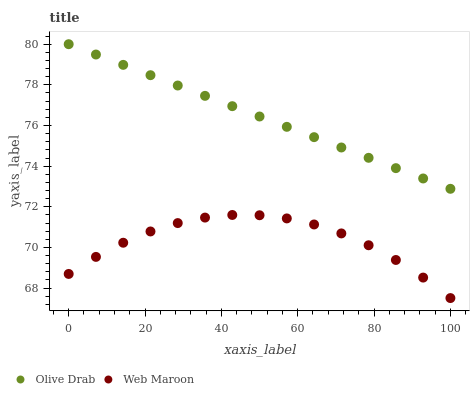Does Web Maroon have the minimum area under the curve?
Answer yes or no. Yes. Does Olive Drab have the maximum area under the curve?
Answer yes or no. Yes. Does Olive Drab have the minimum area under the curve?
Answer yes or no. No. Is Olive Drab the smoothest?
Answer yes or no. Yes. Is Web Maroon the roughest?
Answer yes or no. Yes. Is Olive Drab the roughest?
Answer yes or no. No. Does Web Maroon have the lowest value?
Answer yes or no. Yes. Does Olive Drab have the lowest value?
Answer yes or no. No. Does Olive Drab have the highest value?
Answer yes or no. Yes. Is Web Maroon less than Olive Drab?
Answer yes or no. Yes. Is Olive Drab greater than Web Maroon?
Answer yes or no. Yes. Does Web Maroon intersect Olive Drab?
Answer yes or no. No. 